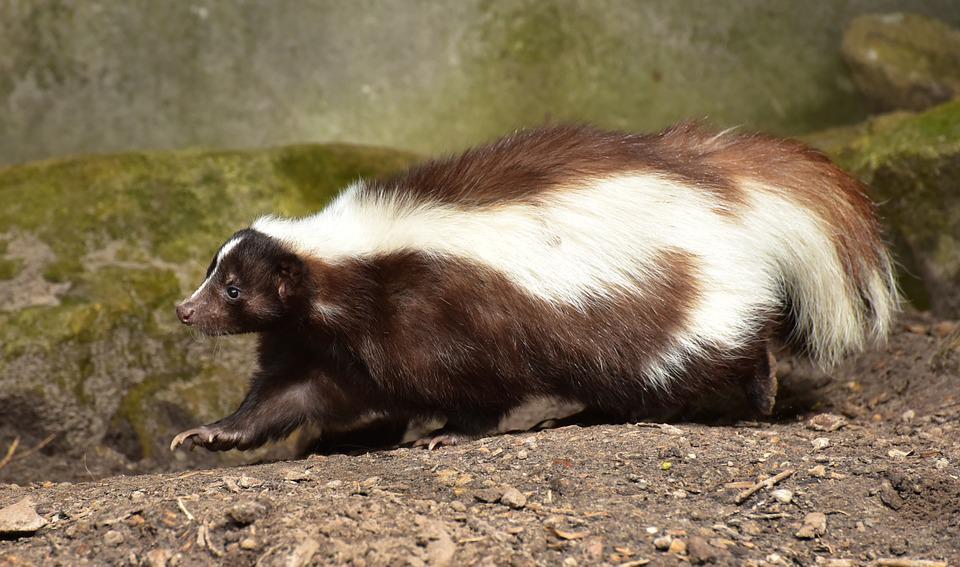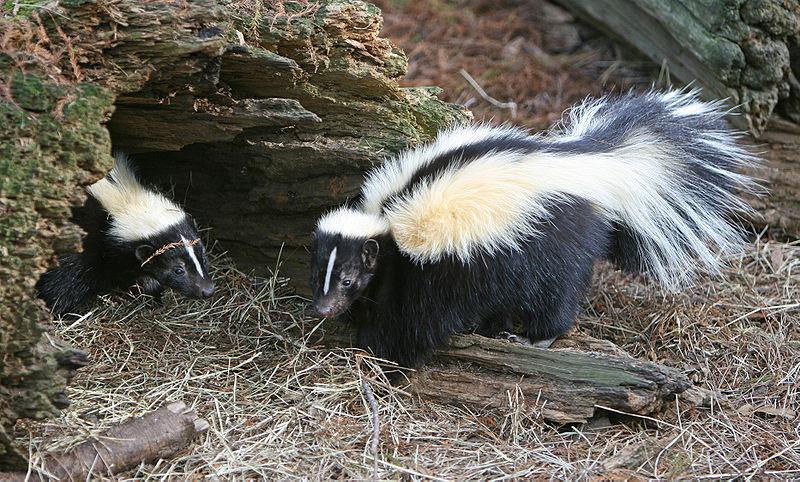The first image is the image on the left, the second image is the image on the right. Given the left and right images, does the statement "The single skunk on the right has a bold straight white stripe and stands in profile, and the single skunk on the left has curving, maze-like stripes." hold true? Answer yes or no. No. The first image is the image on the left, the second image is the image on the right. Examine the images to the left and right. Is the description "One tail is a solid color." accurate? Answer yes or no. No. 